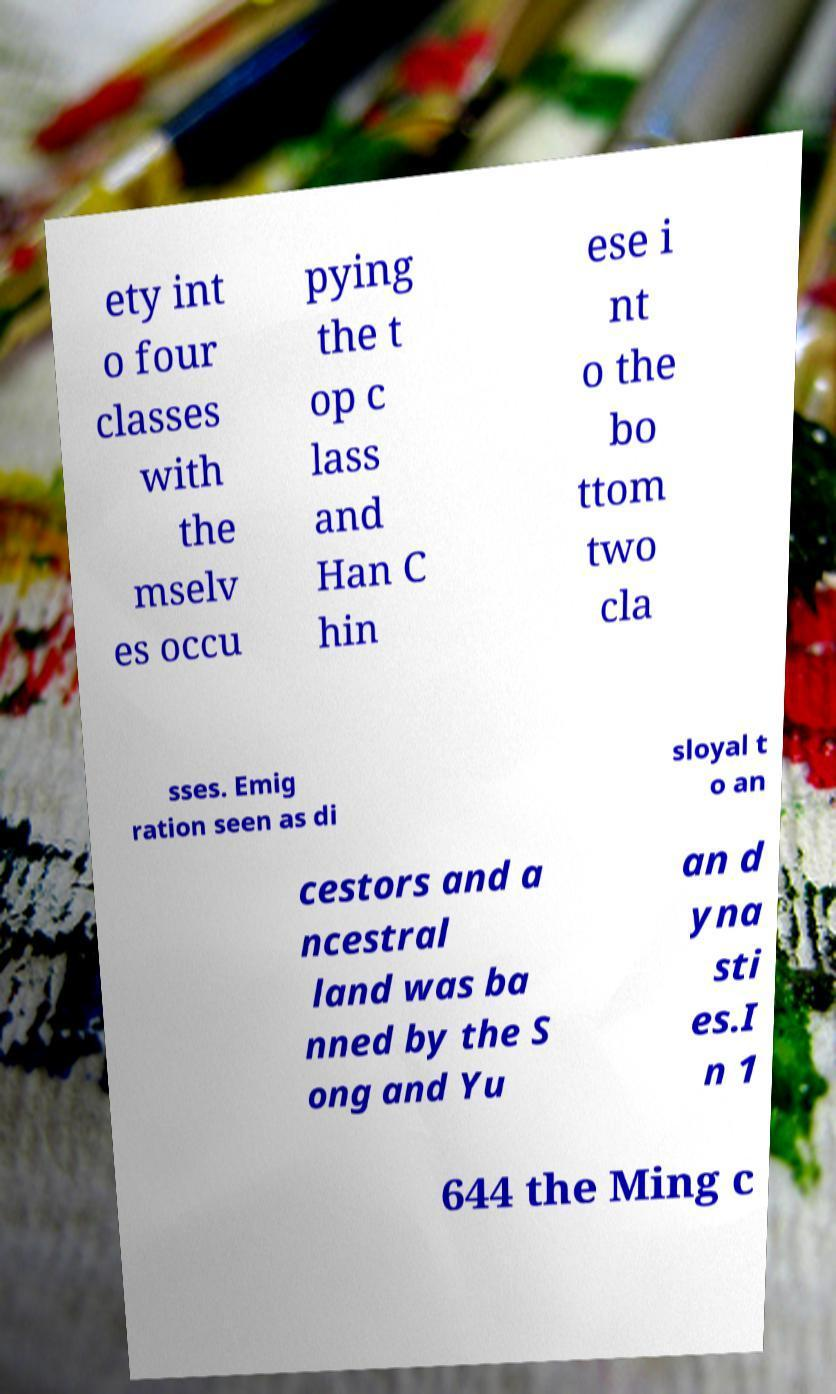Can you read and provide the text displayed in the image?This photo seems to have some interesting text. Can you extract and type it out for me? ety int o four classes with the mselv es occu pying the t op c lass and Han C hin ese i nt o the bo ttom two cla sses. Emig ration seen as di sloyal t o an cestors and a ncestral land was ba nned by the S ong and Yu an d yna sti es.I n 1 644 the Ming c 